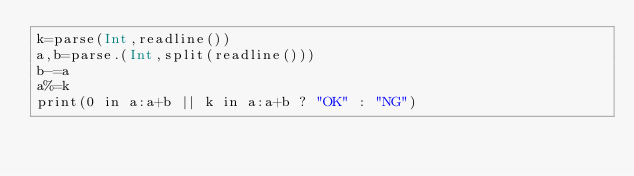<code> <loc_0><loc_0><loc_500><loc_500><_Julia_>k=parse(Int,readline())
a,b=parse.(Int,split(readline()))
b-=a
a%=k
print(0 in a:a+b || k in a:a+b ? "OK" : "NG")</code> 